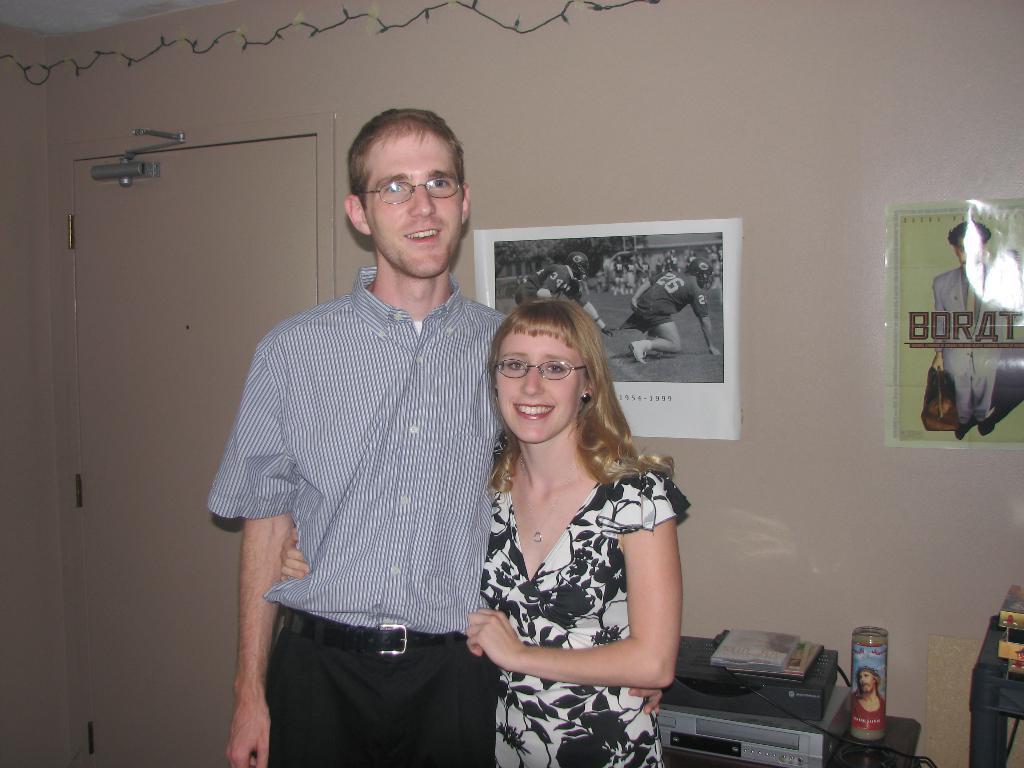Could you give a brief overview of what you see in this image? In this image I can see two people standing and wearing different color dress. Back I can see a door,lights and papers are attached to the wall. I can see Cd-player and some objects on the table. 